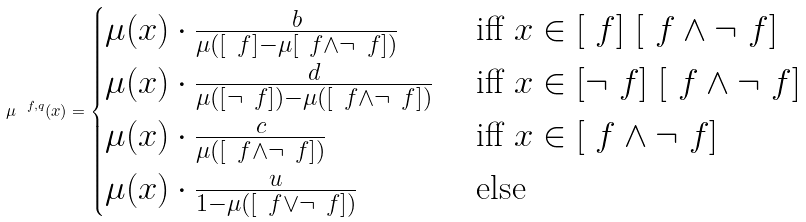Convert formula to latex. <formula><loc_0><loc_0><loc_500><loc_500>\mu ^ { \ f , q } ( x ) = \begin{cases} \mu ( x ) \cdot \frac { b } { \mu ( [ \ f ] - \mu [ \ f \wedge \neg \ f ] ) } & \text { iff } x \in [ \ f ] \ [ \ f \wedge \neg \ f ] \\ \mu ( x ) \cdot \frac { d } { \mu ( [ \neg \ f ] ) - \mu ( [ \ f \wedge \neg \ f ] ) } & \text { iff } x \in [ \neg \ f ] \ [ \ f \wedge \neg \ f ] \\ \mu ( x ) \cdot \frac { c } { \mu ( [ \ f \wedge \neg \ f ] ) } & \text { iff } x \in [ \ f \wedge \neg \ f ] \\ \mu ( x ) \cdot \frac { u } { 1 - \mu ( [ \ f \vee \neg \ f ] ) } & \text { else } \end{cases}</formula> 